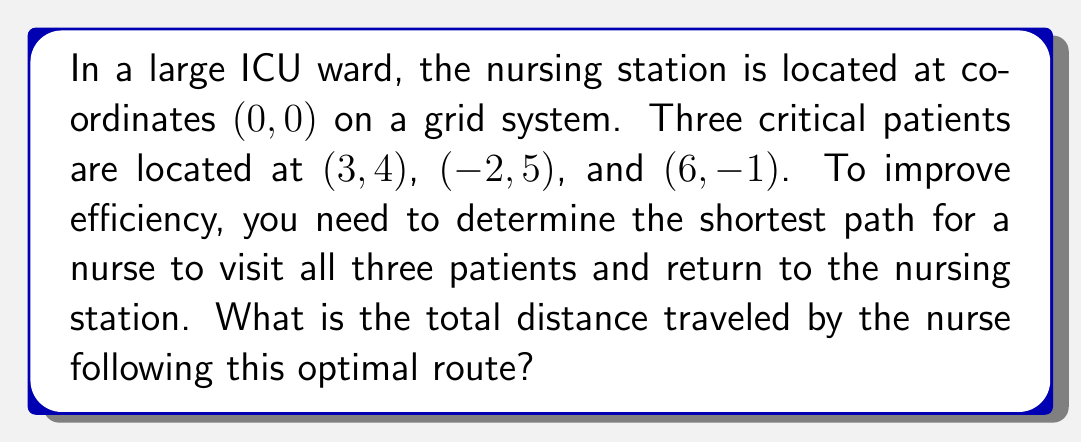Show me your answer to this math problem. To solve this problem, we need to follow these steps:

1. Identify all possible routes:
   There are 6 possible routes to visit all three patients and return to the station.

2. Calculate the distance for each route:
   We can use the distance formula between two points: 
   $$d = \sqrt{(x_2-x_1)^2 + (y_2-y_1)^2}$$

3. Compare the total distances and choose the shortest one.

Let's label the points:
A (0, 0): Nursing station
B (3, 4): Patient 1
C (-2, 5): Patient 2
D (6, -1): Patient 3

Calculate distances between each pair of points:

AB = $\sqrt{(3-0)^2 + (4-0)^2} = 5$
AC = $\sqrt{(-2-0)^2 + (5-0)^2} = \sqrt{29}$
AD = $\sqrt{(6-0)^2 + (-1-0)^2} = \sqrt{37}$
BC = $\sqrt{(-2-3)^2 + (5-4)^2} = \sqrt{26}$
BD = $\sqrt{(6-3)^2 + (-1-4)^2} = \sqrt{34}$
CD = $\sqrt{(6-(-2))^2 + (-1-5)^2} = \sqrt{116}$

Now, calculate the total distance for each route:

1. A-B-C-D-A: $5 + \sqrt{26} + \sqrt{116} + \sqrt{37}$
2. A-B-D-C-A: $5 + \sqrt{34} + \sqrt{116} + \sqrt{29}$
3. A-C-B-D-A: $\sqrt{29} + \sqrt{26} + \sqrt{34} + \sqrt{37}$
4. A-C-D-B-A: $\sqrt{29} + \sqrt{116} + \sqrt{34} + 5$
5. A-D-B-C-A: $\sqrt{37} + \sqrt{34} + \sqrt{26} + \sqrt{29}$
6. A-D-C-B-A: $\sqrt{37} + \sqrt{116} + \sqrt{26} + 5$

Calculating these values, we find that route 5 (A-D-B-C-A) gives the shortest total distance.
Answer: The shortest path for the nurse is A-D-B-C-A, with a total distance of approximately 24.08 units. 